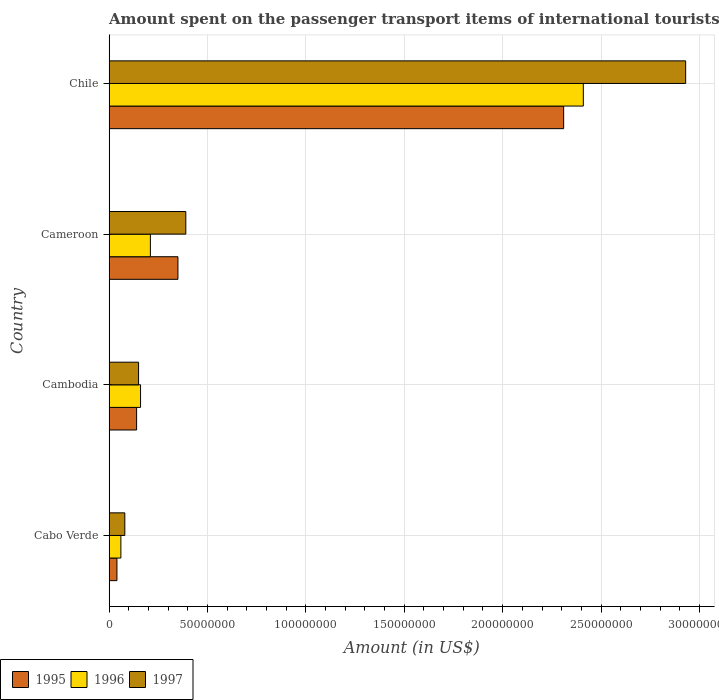How many groups of bars are there?
Offer a terse response. 4. What is the amount spent on the passenger transport items of international tourists in 1997 in Chile?
Provide a succinct answer. 2.93e+08. Across all countries, what is the maximum amount spent on the passenger transport items of international tourists in 1995?
Your response must be concise. 2.31e+08. Across all countries, what is the minimum amount spent on the passenger transport items of international tourists in 1996?
Offer a terse response. 6.00e+06. In which country was the amount spent on the passenger transport items of international tourists in 1997 minimum?
Offer a very short reply. Cabo Verde. What is the total amount spent on the passenger transport items of international tourists in 1996 in the graph?
Ensure brevity in your answer.  2.84e+08. What is the difference between the amount spent on the passenger transport items of international tourists in 1996 in Cameroon and that in Chile?
Offer a very short reply. -2.20e+08. What is the difference between the amount spent on the passenger transport items of international tourists in 1997 in Cameroon and the amount spent on the passenger transport items of international tourists in 1995 in Cambodia?
Offer a very short reply. 2.50e+07. What is the average amount spent on the passenger transport items of international tourists in 1996 per country?
Provide a succinct answer. 7.10e+07. What is the difference between the amount spent on the passenger transport items of international tourists in 1996 and amount spent on the passenger transport items of international tourists in 1997 in Cameroon?
Offer a terse response. -1.80e+07. In how many countries, is the amount spent on the passenger transport items of international tourists in 1996 greater than 160000000 US$?
Your response must be concise. 1. What is the ratio of the amount spent on the passenger transport items of international tourists in 1995 in Cabo Verde to that in Cambodia?
Provide a short and direct response. 0.29. Is the difference between the amount spent on the passenger transport items of international tourists in 1996 in Cambodia and Cameroon greater than the difference between the amount spent on the passenger transport items of international tourists in 1997 in Cambodia and Cameroon?
Provide a succinct answer. Yes. What is the difference between the highest and the second highest amount spent on the passenger transport items of international tourists in 1997?
Your answer should be compact. 2.54e+08. What is the difference between the highest and the lowest amount spent on the passenger transport items of international tourists in 1996?
Your response must be concise. 2.35e+08. In how many countries, is the amount spent on the passenger transport items of international tourists in 1995 greater than the average amount spent on the passenger transport items of international tourists in 1995 taken over all countries?
Your answer should be very brief. 1. Is the sum of the amount spent on the passenger transport items of international tourists in 1996 in Cabo Verde and Cameroon greater than the maximum amount spent on the passenger transport items of international tourists in 1995 across all countries?
Keep it short and to the point. No. What does the 3rd bar from the top in Cameroon represents?
Provide a short and direct response. 1995. Are all the bars in the graph horizontal?
Your response must be concise. Yes. How many countries are there in the graph?
Your response must be concise. 4. Are the values on the major ticks of X-axis written in scientific E-notation?
Ensure brevity in your answer.  No. Does the graph contain any zero values?
Offer a very short reply. No. Where does the legend appear in the graph?
Your response must be concise. Bottom left. How many legend labels are there?
Your answer should be compact. 3. What is the title of the graph?
Give a very brief answer. Amount spent on the passenger transport items of international tourists. What is the label or title of the X-axis?
Provide a short and direct response. Amount (in US$). What is the label or title of the Y-axis?
Make the answer very short. Country. What is the Amount (in US$) in 1996 in Cabo Verde?
Offer a very short reply. 6.00e+06. What is the Amount (in US$) in 1997 in Cabo Verde?
Your answer should be very brief. 8.00e+06. What is the Amount (in US$) in 1995 in Cambodia?
Keep it short and to the point. 1.40e+07. What is the Amount (in US$) of 1996 in Cambodia?
Your answer should be very brief. 1.60e+07. What is the Amount (in US$) in 1997 in Cambodia?
Offer a terse response. 1.50e+07. What is the Amount (in US$) of 1995 in Cameroon?
Provide a succinct answer. 3.50e+07. What is the Amount (in US$) of 1996 in Cameroon?
Ensure brevity in your answer.  2.10e+07. What is the Amount (in US$) of 1997 in Cameroon?
Your answer should be compact. 3.90e+07. What is the Amount (in US$) in 1995 in Chile?
Give a very brief answer. 2.31e+08. What is the Amount (in US$) in 1996 in Chile?
Provide a short and direct response. 2.41e+08. What is the Amount (in US$) in 1997 in Chile?
Offer a terse response. 2.93e+08. Across all countries, what is the maximum Amount (in US$) of 1995?
Your answer should be compact. 2.31e+08. Across all countries, what is the maximum Amount (in US$) of 1996?
Your answer should be compact. 2.41e+08. Across all countries, what is the maximum Amount (in US$) in 1997?
Your answer should be compact. 2.93e+08. Across all countries, what is the minimum Amount (in US$) of 1995?
Your answer should be very brief. 4.00e+06. Across all countries, what is the minimum Amount (in US$) of 1996?
Make the answer very short. 6.00e+06. What is the total Amount (in US$) of 1995 in the graph?
Ensure brevity in your answer.  2.84e+08. What is the total Amount (in US$) of 1996 in the graph?
Your answer should be very brief. 2.84e+08. What is the total Amount (in US$) of 1997 in the graph?
Your answer should be compact. 3.55e+08. What is the difference between the Amount (in US$) in 1995 in Cabo Verde and that in Cambodia?
Ensure brevity in your answer.  -1.00e+07. What is the difference between the Amount (in US$) in 1996 in Cabo Verde and that in Cambodia?
Provide a succinct answer. -1.00e+07. What is the difference between the Amount (in US$) of 1997 in Cabo Verde and that in Cambodia?
Your answer should be compact. -7.00e+06. What is the difference between the Amount (in US$) of 1995 in Cabo Verde and that in Cameroon?
Keep it short and to the point. -3.10e+07. What is the difference between the Amount (in US$) in 1996 in Cabo Verde and that in Cameroon?
Ensure brevity in your answer.  -1.50e+07. What is the difference between the Amount (in US$) in 1997 in Cabo Verde and that in Cameroon?
Your answer should be very brief. -3.10e+07. What is the difference between the Amount (in US$) in 1995 in Cabo Verde and that in Chile?
Make the answer very short. -2.27e+08. What is the difference between the Amount (in US$) in 1996 in Cabo Verde and that in Chile?
Your answer should be very brief. -2.35e+08. What is the difference between the Amount (in US$) of 1997 in Cabo Verde and that in Chile?
Keep it short and to the point. -2.85e+08. What is the difference between the Amount (in US$) in 1995 in Cambodia and that in Cameroon?
Your answer should be compact. -2.10e+07. What is the difference between the Amount (in US$) of 1996 in Cambodia and that in Cameroon?
Provide a succinct answer. -5.00e+06. What is the difference between the Amount (in US$) of 1997 in Cambodia and that in Cameroon?
Make the answer very short. -2.40e+07. What is the difference between the Amount (in US$) in 1995 in Cambodia and that in Chile?
Your response must be concise. -2.17e+08. What is the difference between the Amount (in US$) of 1996 in Cambodia and that in Chile?
Provide a short and direct response. -2.25e+08. What is the difference between the Amount (in US$) in 1997 in Cambodia and that in Chile?
Offer a terse response. -2.78e+08. What is the difference between the Amount (in US$) of 1995 in Cameroon and that in Chile?
Make the answer very short. -1.96e+08. What is the difference between the Amount (in US$) in 1996 in Cameroon and that in Chile?
Make the answer very short. -2.20e+08. What is the difference between the Amount (in US$) of 1997 in Cameroon and that in Chile?
Offer a very short reply. -2.54e+08. What is the difference between the Amount (in US$) in 1995 in Cabo Verde and the Amount (in US$) in 1996 in Cambodia?
Your answer should be compact. -1.20e+07. What is the difference between the Amount (in US$) of 1995 in Cabo Verde and the Amount (in US$) of 1997 in Cambodia?
Provide a succinct answer. -1.10e+07. What is the difference between the Amount (in US$) in 1996 in Cabo Verde and the Amount (in US$) in 1997 in Cambodia?
Keep it short and to the point. -9.00e+06. What is the difference between the Amount (in US$) in 1995 in Cabo Verde and the Amount (in US$) in 1996 in Cameroon?
Ensure brevity in your answer.  -1.70e+07. What is the difference between the Amount (in US$) in 1995 in Cabo Verde and the Amount (in US$) in 1997 in Cameroon?
Ensure brevity in your answer.  -3.50e+07. What is the difference between the Amount (in US$) in 1996 in Cabo Verde and the Amount (in US$) in 1997 in Cameroon?
Offer a terse response. -3.30e+07. What is the difference between the Amount (in US$) in 1995 in Cabo Verde and the Amount (in US$) in 1996 in Chile?
Keep it short and to the point. -2.37e+08. What is the difference between the Amount (in US$) of 1995 in Cabo Verde and the Amount (in US$) of 1997 in Chile?
Give a very brief answer. -2.89e+08. What is the difference between the Amount (in US$) of 1996 in Cabo Verde and the Amount (in US$) of 1997 in Chile?
Provide a short and direct response. -2.87e+08. What is the difference between the Amount (in US$) of 1995 in Cambodia and the Amount (in US$) of 1996 in Cameroon?
Ensure brevity in your answer.  -7.00e+06. What is the difference between the Amount (in US$) in 1995 in Cambodia and the Amount (in US$) in 1997 in Cameroon?
Provide a succinct answer. -2.50e+07. What is the difference between the Amount (in US$) of 1996 in Cambodia and the Amount (in US$) of 1997 in Cameroon?
Your response must be concise. -2.30e+07. What is the difference between the Amount (in US$) of 1995 in Cambodia and the Amount (in US$) of 1996 in Chile?
Offer a very short reply. -2.27e+08. What is the difference between the Amount (in US$) of 1995 in Cambodia and the Amount (in US$) of 1997 in Chile?
Ensure brevity in your answer.  -2.79e+08. What is the difference between the Amount (in US$) of 1996 in Cambodia and the Amount (in US$) of 1997 in Chile?
Make the answer very short. -2.77e+08. What is the difference between the Amount (in US$) of 1995 in Cameroon and the Amount (in US$) of 1996 in Chile?
Give a very brief answer. -2.06e+08. What is the difference between the Amount (in US$) in 1995 in Cameroon and the Amount (in US$) in 1997 in Chile?
Provide a short and direct response. -2.58e+08. What is the difference between the Amount (in US$) of 1996 in Cameroon and the Amount (in US$) of 1997 in Chile?
Your answer should be very brief. -2.72e+08. What is the average Amount (in US$) of 1995 per country?
Your answer should be very brief. 7.10e+07. What is the average Amount (in US$) of 1996 per country?
Make the answer very short. 7.10e+07. What is the average Amount (in US$) in 1997 per country?
Offer a terse response. 8.88e+07. What is the difference between the Amount (in US$) of 1995 and Amount (in US$) of 1996 in Cabo Verde?
Keep it short and to the point. -2.00e+06. What is the difference between the Amount (in US$) of 1996 and Amount (in US$) of 1997 in Cabo Verde?
Keep it short and to the point. -2.00e+06. What is the difference between the Amount (in US$) in 1995 and Amount (in US$) in 1997 in Cambodia?
Give a very brief answer. -1.00e+06. What is the difference between the Amount (in US$) in 1996 and Amount (in US$) in 1997 in Cambodia?
Offer a terse response. 1.00e+06. What is the difference between the Amount (in US$) of 1995 and Amount (in US$) of 1996 in Cameroon?
Ensure brevity in your answer.  1.40e+07. What is the difference between the Amount (in US$) of 1996 and Amount (in US$) of 1997 in Cameroon?
Your answer should be compact. -1.80e+07. What is the difference between the Amount (in US$) in 1995 and Amount (in US$) in 1996 in Chile?
Ensure brevity in your answer.  -1.00e+07. What is the difference between the Amount (in US$) of 1995 and Amount (in US$) of 1997 in Chile?
Your answer should be compact. -6.20e+07. What is the difference between the Amount (in US$) in 1996 and Amount (in US$) in 1997 in Chile?
Ensure brevity in your answer.  -5.20e+07. What is the ratio of the Amount (in US$) in 1995 in Cabo Verde to that in Cambodia?
Keep it short and to the point. 0.29. What is the ratio of the Amount (in US$) in 1997 in Cabo Verde to that in Cambodia?
Ensure brevity in your answer.  0.53. What is the ratio of the Amount (in US$) of 1995 in Cabo Verde to that in Cameroon?
Give a very brief answer. 0.11. What is the ratio of the Amount (in US$) in 1996 in Cabo Verde to that in Cameroon?
Provide a short and direct response. 0.29. What is the ratio of the Amount (in US$) of 1997 in Cabo Verde to that in Cameroon?
Your answer should be compact. 0.21. What is the ratio of the Amount (in US$) of 1995 in Cabo Verde to that in Chile?
Your answer should be very brief. 0.02. What is the ratio of the Amount (in US$) in 1996 in Cabo Verde to that in Chile?
Provide a short and direct response. 0.02. What is the ratio of the Amount (in US$) in 1997 in Cabo Verde to that in Chile?
Keep it short and to the point. 0.03. What is the ratio of the Amount (in US$) in 1996 in Cambodia to that in Cameroon?
Ensure brevity in your answer.  0.76. What is the ratio of the Amount (in US$) of 1997 in Cambodia to that in Cameroon?
Make the answer very short. 0.38. What is the ratio of the Amount (in US$) of 1995 in Cambodia to that in Chile?
Provide a succinct answer. 0.06. What is the ratio of the Amount (in US$) of 1996 in Cambodia to that in Chile?
Make the answer very short. 0.07. What is the ratio of the Amount (in US$) in 1997 in Cambodia to that in Chile?
Offer a very short reply. 0.05. What is the ratio of the Amount (in US$) in 1995 in Cameroon to that in Chile?
Offer a terse response. 0.15. What is the ratio of the Amount (in US$) of 1996 in Cameroon to that in Chile?
Ensure brevity in your answer.  0.09. What is the ratio of the Amount (in US$) in 1997 in Cameroon to that in Chile?
Your response must be concise. 0.13. What is the difference between the highest and the second highest Amount (in US$) in 1995?
Offer a very short reply. 1.96e+08. What is the difference between the highest and the second highest Amount (in US$) in 1996?
Ensure brevity in your answer.  2.20e+08. What is the difference between the highest and the second highest Amount (in US$) in 1997?
Ensure brevity in your answer.  2.54e+08. What is the difference between the highest and the lowest Amount (in US$) in 1995?
Make the answer very short. 2.27e+08. What is the difference between the highest and the lowest Amount (in US$) in 1996?
Provide a succinct answer. 2.35e+08. What is the difference between the highest and the lowest Amount (in US$) of 1997?
Your response must be concise. 2.85e+08. 